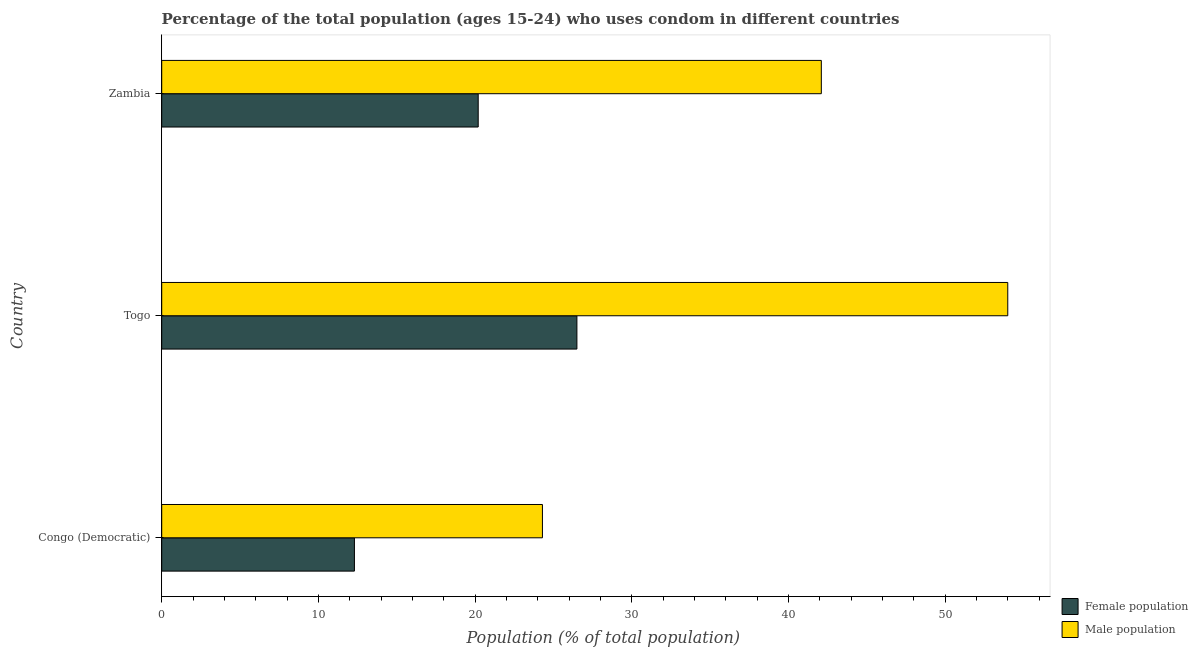Are the number of bars on each tick of the Y-axis equal?
Provide a short and direct response. Yes. How many bars are there on the 3rd tick from the top?
Provide a short and direct response. 2. What is the label of the 1st group of bars from the top?
Keep it short and to the point. Zambia. Across all countries, what is the maximum male population?
Your response must be concise. 54. Across all countries, what is the minimum male population?
Your answer should be very brief. 24.3. In which country was the female population maximum?
Your answer should be compact. Togo. In which country was the female population minimum?
Make the answer very short. Congo (Democratic). What is the total male population in the graph?
Ensure brevity in your answer.  120.4. What is the difference between the male population in Congo (Democratic) and that in Zambia?
Make the answer very short. -17.8. What is the difference between the female population in Zambia and the male population in Congo (Democratic)?
Your response must be concise. -4.1. What is the average female population per country?
Your response must be concise. 19.67. What is the difference between the male population and female population in Zambia?
Give a very brief answer. 21.9. In how many countries, is the female population greater than 30 %?
Provide a short and direct response. 0. What is the ratio of the female population in Congo (Democratic) to that in Togo?
Your response must be concise. 0.46. Is the male population in Congo (Democratic) less than that in Zambia?
Offer a very short reply. Yes. Is the difference between the female population in Congo (Democratic) and Togo greater than the difference between the male population in Congo (Democratic) and Togo?
Your response must be concise. Yes. What is the difference between the highest and the lowest male population?
Make the answer very short. 29.7. What does the 2nd bar from the top in Zambia represents?
Your answer should be very brief. Female population. What does the 1st bar from the bottom in Congo (Democratic) represents?
Keep it short and to the point. Female population. Are all the bars in the graph horizontal?
Provide a succinct answer. Yes. How many countries are there in the graph?
Provide a short and direct response. 3. What is the difference between two consecutive major ticks on the X-axis?
Give a very brief answer. 10. Does the graph contain grids?
Provide a succinct answer. No. Where does the legend appear in the graph?
Offer a terse response. Bottom right. How many legend labels are there?
Ensure brevity in your answer.  2. How are the legend labels stacked?
Your response must be concise. Vertical. What is the title of the graph?
Your response must be concise. Percentage of the total population (ages 15-24) who uses condom in different countries. Does "Adolescent fertility rate" appear as one of the legend labels in the graph?
Provide a succinct answer. No. What is the label or title of the X-axis?
Your answer should be compact. Population (% of total population) . What is the label or title of the Y-axis?
Give a very brief answer. Country. What is the Population (% of total population)  of Female population in Congo (Democratic)?
Your answer should be very brief. 12.3. What is the Population (% of total population)  of Male population in Congo (Democratic)?
Offer a terse response. 24.3. What is the Population (% of total population)  in Female population in Togo?
Your answer should be very brief. 26.5. What is the Population (% of total population)  of Male population in Togo?
Provide a short and direct response. 54. What is the Population (% of total population)  of Female population in Zambia?
Give a very brief answer. 20.2. What is the Population (% of total population)  in Male population in Zambia?
Your answer should be compact. 42.1. Across all countries, what is the maximum Population (% of total population)  of Female population?
Your response must be concise. 26.5. Across all countries, what is the minimum Population (% of total population)  in Male population?
Your answer should be compact. 24.3. What is the total Population (% of total population)  of Male population in the graph?
Your answer should be very brief. 120.4. What is the difference between the Population (% of total population)  in Male population in Congo (Democratic) and that in Togo?
Make the answer very short. -29.7. What is the difference between the Population (% of total population)  of Female population in Congo (Democratic) and that in Zambia?
Provide a succinct answer. -7.9. What is the difference between the Population (% of total population)  of Male population in Congo (Democratic) and that in Zambia?
Provide a succinct answer. -17.8. What is the difference between the Population (% of total population)  in Female population in Congo (Democratic) and the Population (% of total population)  in Male population in Togo?
Provide a succinct answer. -41.7. What is the difference between the Population (% of total population)  of Female population in Congo (Democratic) and the Population (% of total population)  of Male population in Zambia?
Your response must be concise. -29.8. What is the difference between the Population (% of total population)  in Female population in Togo and the Population (% of total population)  in Male population in Zambia?
Provide a succinct answer. -15.6. What is the average Population (% of total population)  in Female population per country?
Keep it short and to the point. 19.67. What is the average Population (% of total population)  in Male population per country?
Your answer should be very brief. 40.13. What is the difference between the Population (% of total population)  in Female population and Population (% of total population)  in Male population in Togo?
Your response must be concise. -27.5. What is the difference between the Population (% of total population)  of Female population and Population (% of total population)  of Male population in Zambia?
Make the answer very short. -21.9. What is the ratio of the Population (% of total population)  in Female population in Congo (Democratic) to that in Togo?
Your answer should be compact. 0.46. What is the ratio of the Population (% of total population)  of Male population in Congo (Democratic) to that in Togo?
Provide a short and direct response. 0.45. What is the ratio of the Population (% of total population)  in Female population in Congo (Democratic) to that in Zambia?
Offer a very short reply. 0.61. What is the ratio of the Population (% of total population)  in Male population in Congo (Democratic) to that in Zambia?
Your answer should be compact. 0.58. What is the ratio of the Population (% of total population)  of Female population in Togo to that in Zambia?
Give a very brief answer. 1.31. What is the ratio of the Population (% of total population)  of Male population in Togo to that in Zambia?
Offer a terse response. 1.28. What is the difference between the highest and the second highest Population (% of total population)  of Female population?
Offer a very short reply. 6.3. What is the difference between the highest and the second highest Population (% of total population)  of Male population?
Your answer should be compact. 11.9. What is the difference between the highest and the lowest Population (% of total population)  in Male population?
Give a very brief answer. 29.7. 